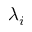<formula> <loc_0><loc_0><loc_500><loc_500>\lambda _ { i }</formula> 